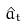<formula> <loc_0><loc_0><loc_500><loc_500>\hat { a } _ { t }</formula> 